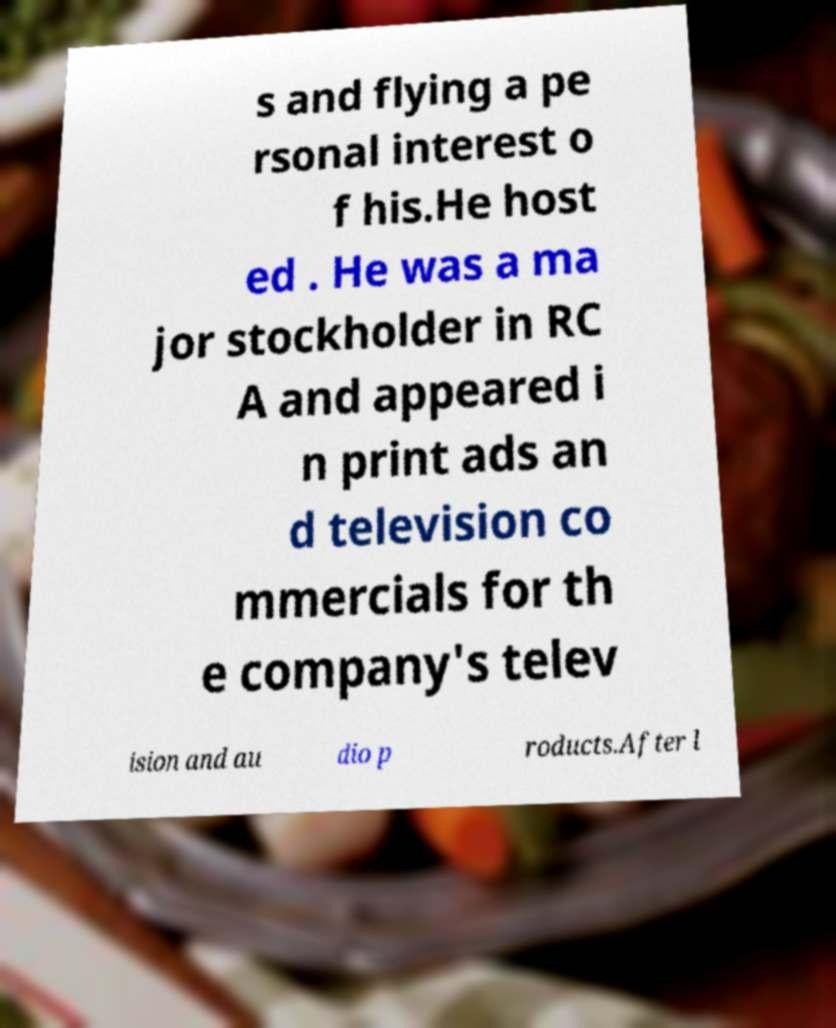Please identify and transcribe the text found in this image. s and flying a pe rsonal interest o f his.He host ed . He was a ma jor stockholder in RC A and appeared i n print ads an d television co mmercials for th e company's telev ision and au dio p roducts.After l 